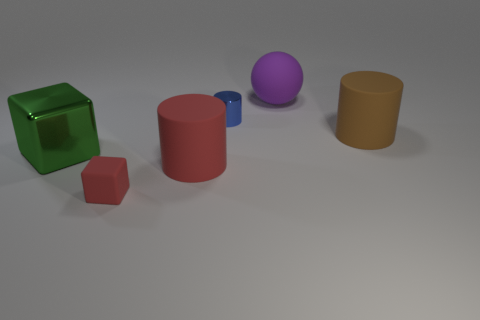What shape is the purple thing that is made of the same material as the brown object?
Give a very brief answer. Sphere. There is a object that is left of the block that is in front of the big cube; how big is it?
Make the answer very short. Large. There is a big red rubber thing; what shape is it?
Your response must be concise. Cylinder. What number of large things are either yellow metal blocks or red rubber blocks?
Make the answer very short. 0. What is the size of the other green thing that is the same shape as the tiny rubber object?
Offer a very short reply. Large. What number of tiny things are both behind the big brown object and in front of the green metallic block?
Offer a terse response. 0. There is a small matte object; is it the same shape as the large thing to the left of the big red thing?
Ensure brevity in your answer.  Yes. Is the number of balls left of the small red rubber thing greater than the number of small green rubber cylinders?
Offer a very short reply. No. Are there fewer big green metal things in front of the blue cylinder than big green blocks?
Your answer should be compact. No. How many large rubber objects have the same color as the matte block?
Make the answer very short. 1. 